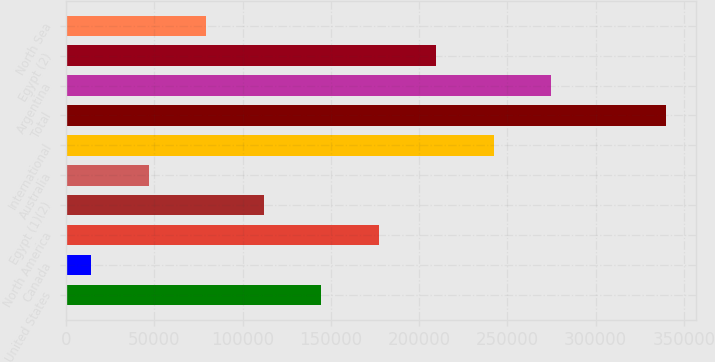<chart> <loc_0><loc_0><loc_500><loc_500><bar_chart><fcel>United States<fcel>Canada<fcel>North America<fcel>Egypt (1)(2)<fcel>Australia<fcel>International<fcel>Total<fcel>Argentina<fcel>Egypt (2)<fcel>North Sea<nl><fcel>144529<fcel>14252<fcel>177098<fcel>111960<fcel>46821.3<fcel>242237<fcel>339945<fcel>274806<fcel>209668<fcel>79390.6<nl></chart> 